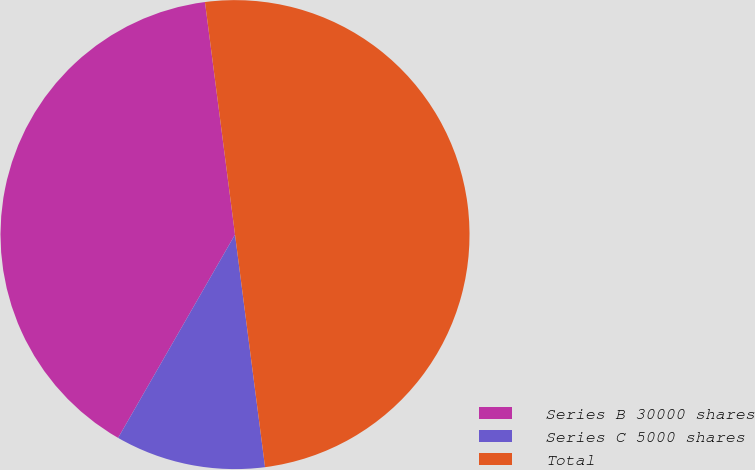Convert chart. <chart><loc_0><loc_0><loc_500><loc_500><pie_chart><fcel>Series B 30000 shares<fcel>Series C 5000 shares<fcel>Total<nl><fcel>39.65%<fcel>10.35%<fcel>50.0%<nl></chart> 